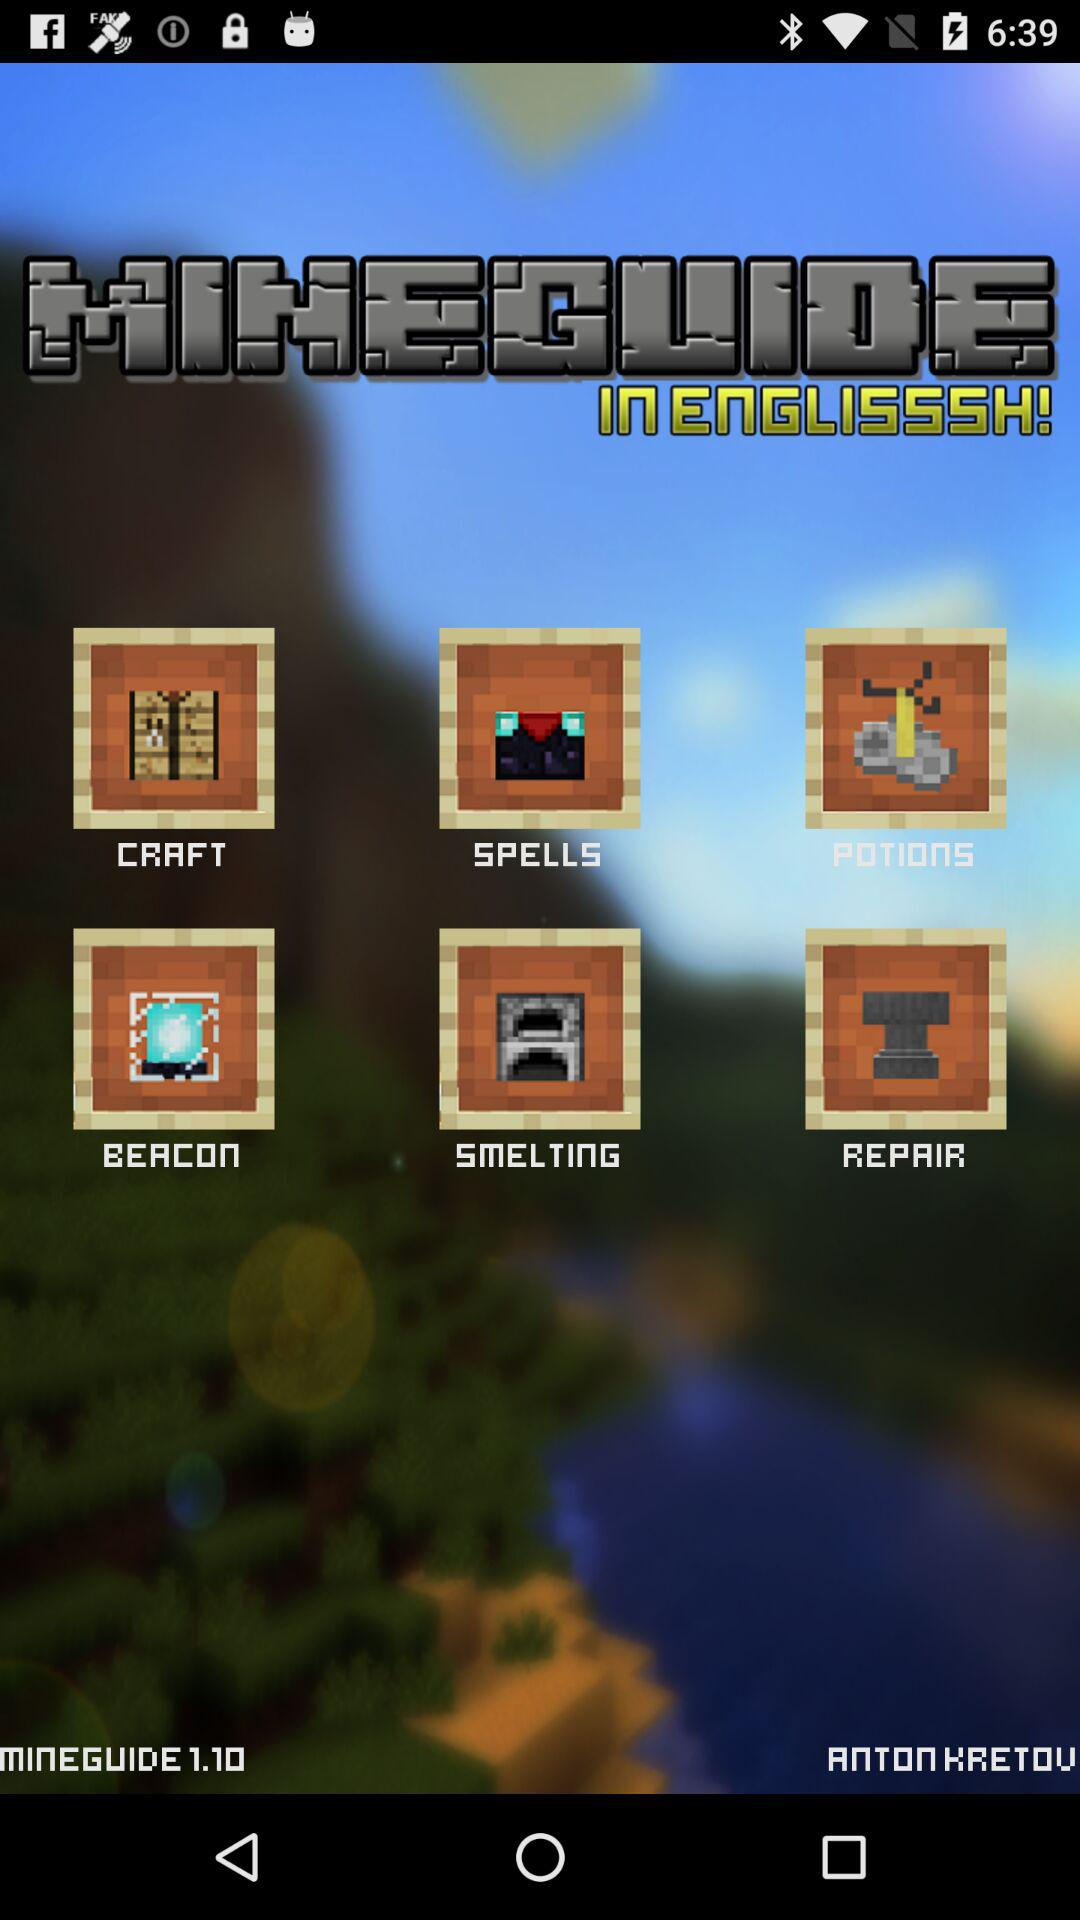What is the application name? The application name is "MINEGUIDE". 